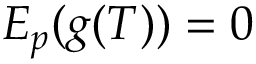<formula> <loc_0><loc_0><loc_500><loc_500>E _ { p } ( g ( T ) ) = 0</formula> 